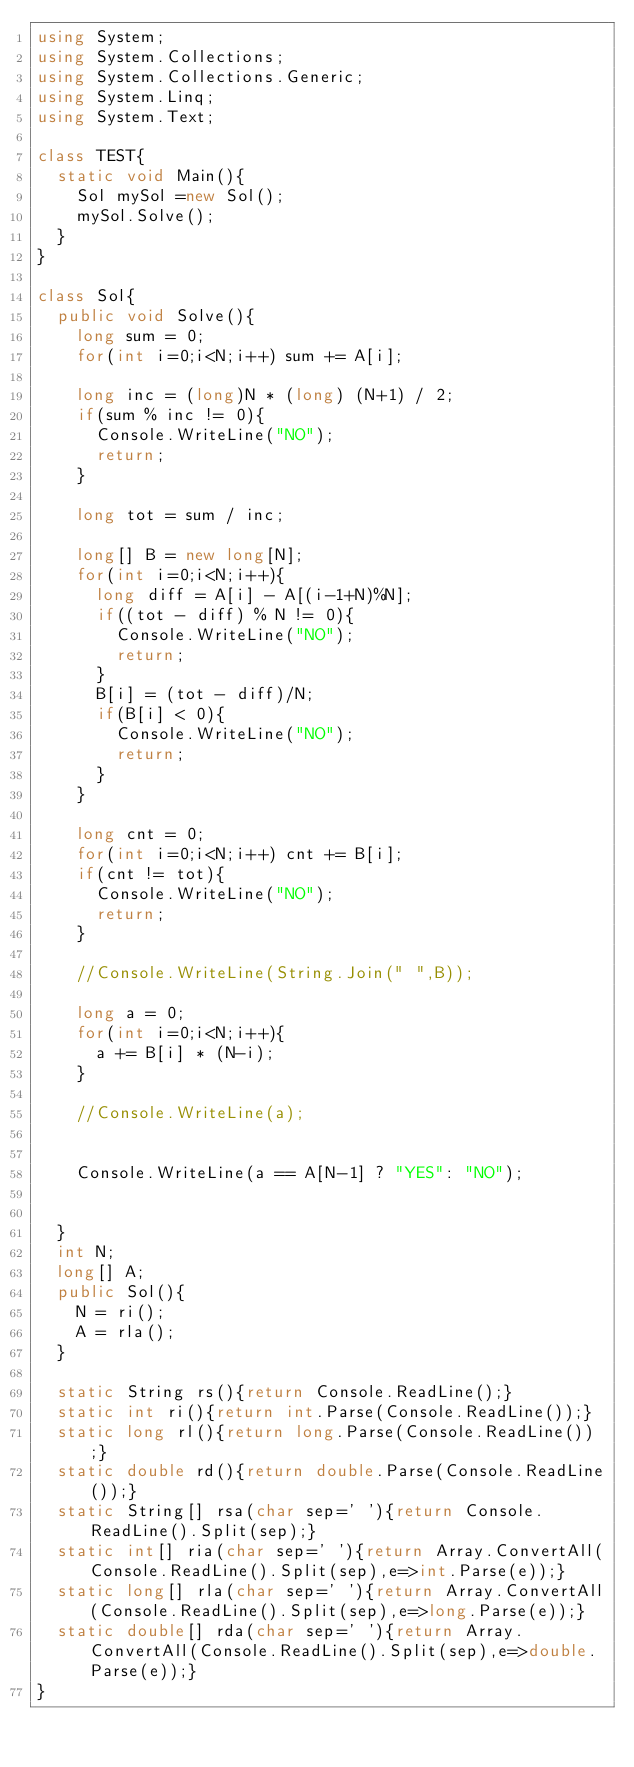Convert code to text. <code><loc_0><loc_0><loc_500><loc_500><_C#_>using System;
using System.Collections;
using System.Collections.Generic;
using System.Linq;
using System.Text;

class TEST{
	static void Main(){
		Sol mySol =new Sol();
		mySol.Solve();
	}
}

class Sol{
	public void Solve(){
		long sum = 0;
		for(int i=0;i<N;i++) sum += A[i];
		
		long inc = (long)N * (long) (N+1) / 2;
		if(sum % inc != 0){
			Console.WriteLine("NO");
			return;
		}
		
		long tot = sum / inc;
		
		long[] B = new long[N];
		for(int i=0;i<N;i++){
			long diff = A[i] - A[(i-1+N)%N];
			if((tot - diff) % N != 0){
				Console.WriteLine("NO");
				return;
			}
			B[i] = (tot - diff)/N;
			if(B[i] < 0){
				Console.WriteLine("NO");
				return;
			}
		}
		
		long cnt = 0;
		for(int i=0;i<N;i++) cnt += B[i];
		if(cnt != tot){
			Console.WriteLine("NO");
			return;
		}
		
		//Console.WriteLine(String.Join(" ",B));
		
		long a = 0;
		for(int i=0;i<N;i++){
			a += B[i] * (N-i);
		}
		
		//Console.WriteLine(a);
		
		
		Console.WriteLine(a == A[N-1] ? "YES": "NO");
		
		
	}
	int N;
	long[] A;
	public Sol(){
		N = ri();
		A = rla();
	}

	static String rs(){return Console.ReadLine();}
	static int ri(){return int.Parse(Console.ReadLine());}
	static long rl(){return long.Parse(Console.ReadLine());}
	static double rd(){return double.Parse(Console.ReadLine());}
	static String[] rsa(char sep=' '){return Console.ReadLine().Split(sep);}
	static int[] ria(char sep=' '){return Array.ConvertAll(Console.ReadLine().Split(sep),e=>int.Parse(e));}
	static long[] rla(char sep=' '){return Array.ConvertAll(Console.ReadLine().Split(sep),e=>long.Parse(e));}
	static double[] rda(char sep=' '){return Array.ConvertAll(Console.ReadLine().Split(sep),e=>double.Parse(e));}
}
</code> 